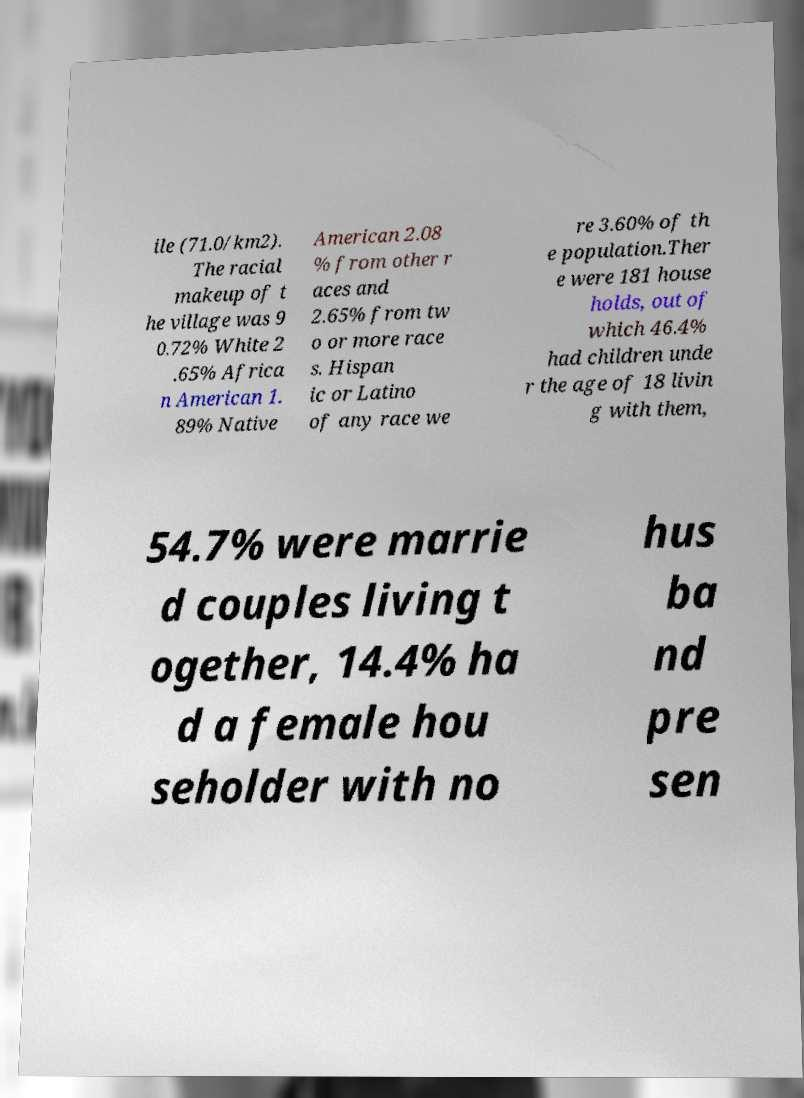I need the written content from this picture converted into text. Can you do that? ile (71.0/km2). The racial makeup of t he village was 9 0.72% White 2 .65% Africa n American 1. 89% Native American 2.08 % from other r aces and 2.65% from tw o or more race s. Hispan ic or Latino of any race we re 3.60% of th e population.Ther e were 181 house holds, out of which 46.4% had children unde r the age of 18 livin g with them, 54.7% were marrie d couples living t ogether, 14.4% ha d a female hou seholder with no hus ba nd pre sen 